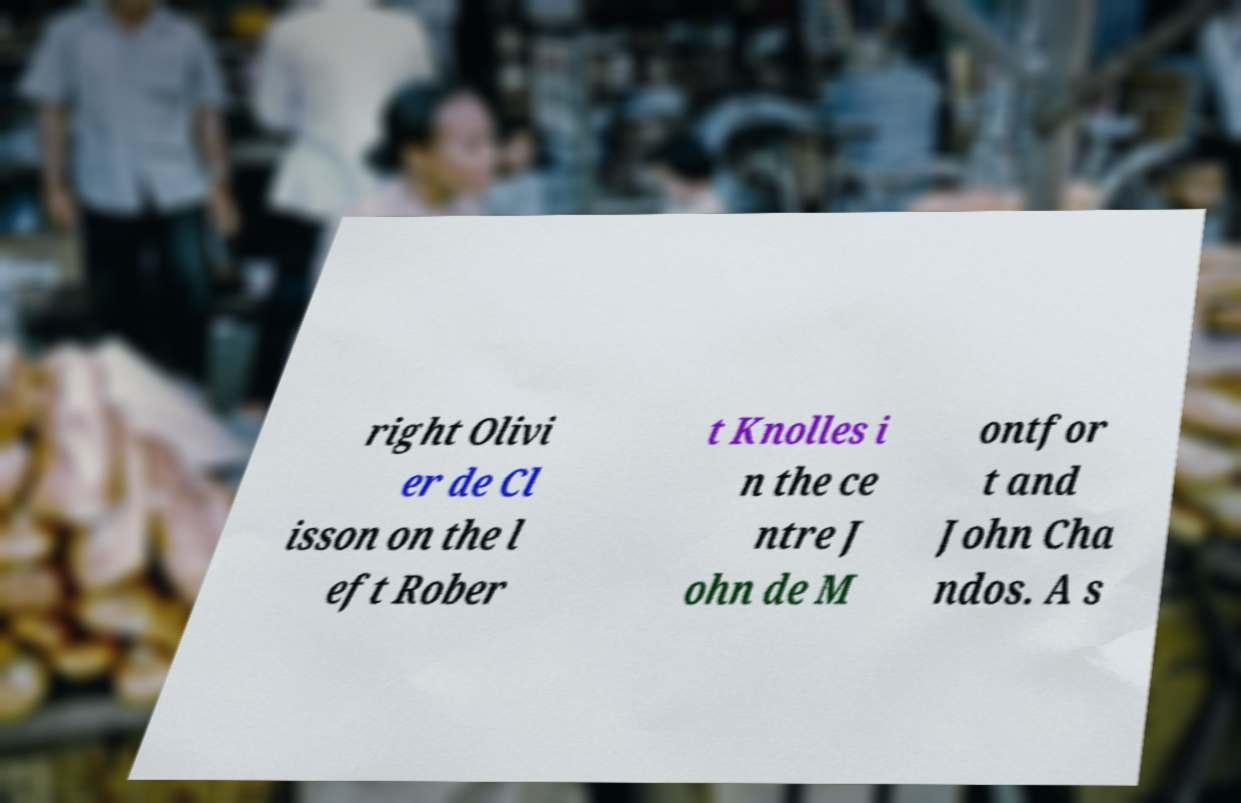Could you extract and type out the text from this image? right Olivi er de Cl isson on the l eft Rober t Knolles i n the ce ntre J ohn de M ontfor t and John Cha ndos. A s 